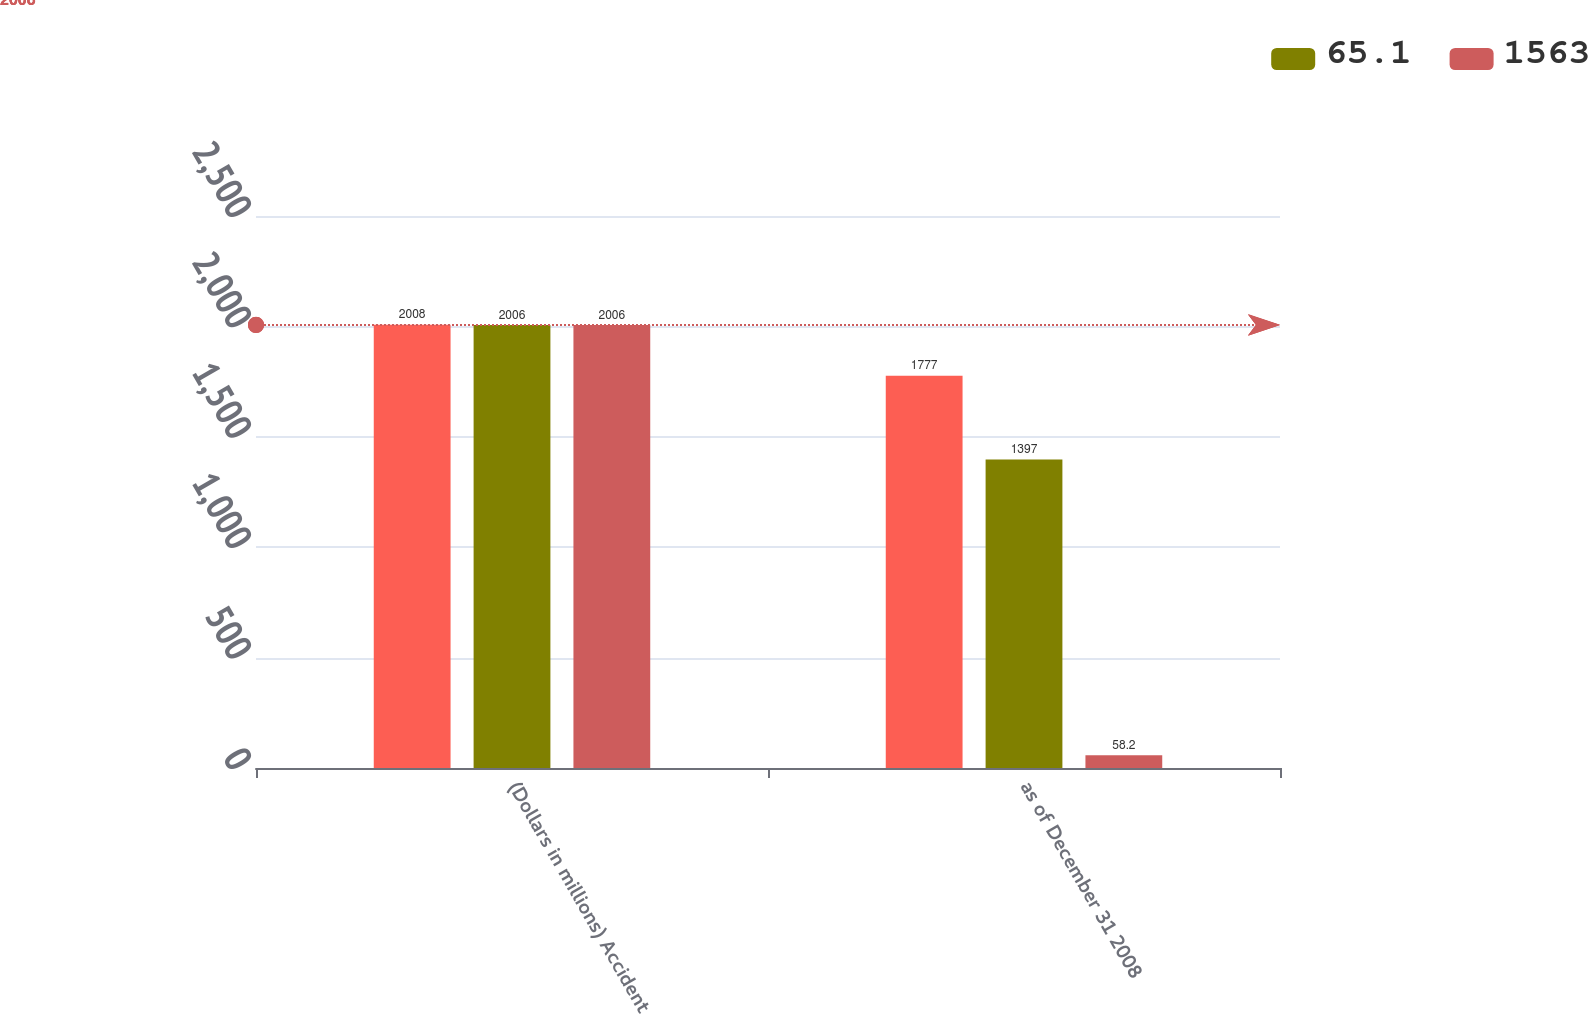<chart> <loc_0><loc_0><loc_500><loc_500><stacked_bar_chart><ecel><fcel>(Dollars in millions) Accident<fcel>as of December 31 2008<nl><fcel>nan<fcel>2008<fcel>1777<nl><fcel>65.1<fcel>2006<fcel>1397<nl><fcel>1563<fcel>2006<fcel>58.2<nl></chart> 